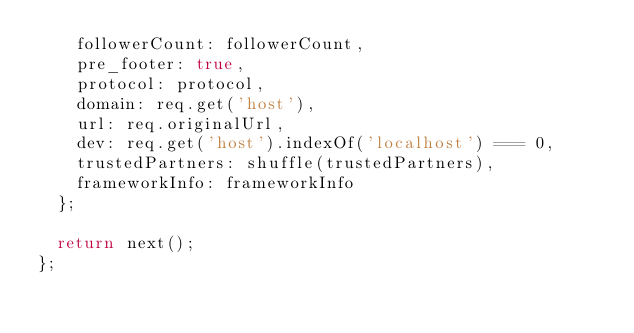Convert code to text. <code><loc_0><loc_0><loc_500><loc_500><_JavaScript_>    followerCount: followerCount,
    pre_footer: true,
    protocol: protocol,
    domain: req.get('host'),
    url: req.originalUrl,
    dev: req.get('host').indexOf('localhost') === 0,
    trustedPartners: shuffle(trustedPartners),
    frameworkInfo: frameworkInfo
  };

  return next();
};
</code> 